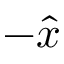<formula> <loc_0><loc_0><loc_500><loc_500>- \hat { x }</formula> 